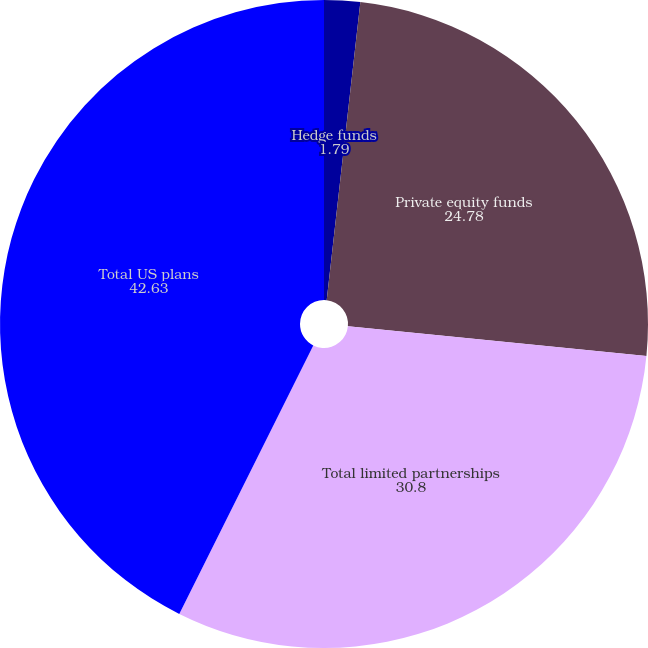<chart> <loc_0><loc_0><loc_500><loc_500><pie_chart><fcel>Hedge funds<fcel>Private equity funds<fcel>Total limited partnerships<fcel>Total US plans<nl><fcel>1.79%<fcel>24.78%<fcel>30.8%<fcel>42.63%<nl></chart> 